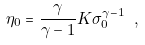Convert formula to latex. <formula><loc_0><loc_0><loc_500><loc_500>\eta _ { 0 } = \frac { \gamma } { \gamma - 1 } K \sigma _ { 0 } ^ { \gamma - 1 } \ ,</formula> 